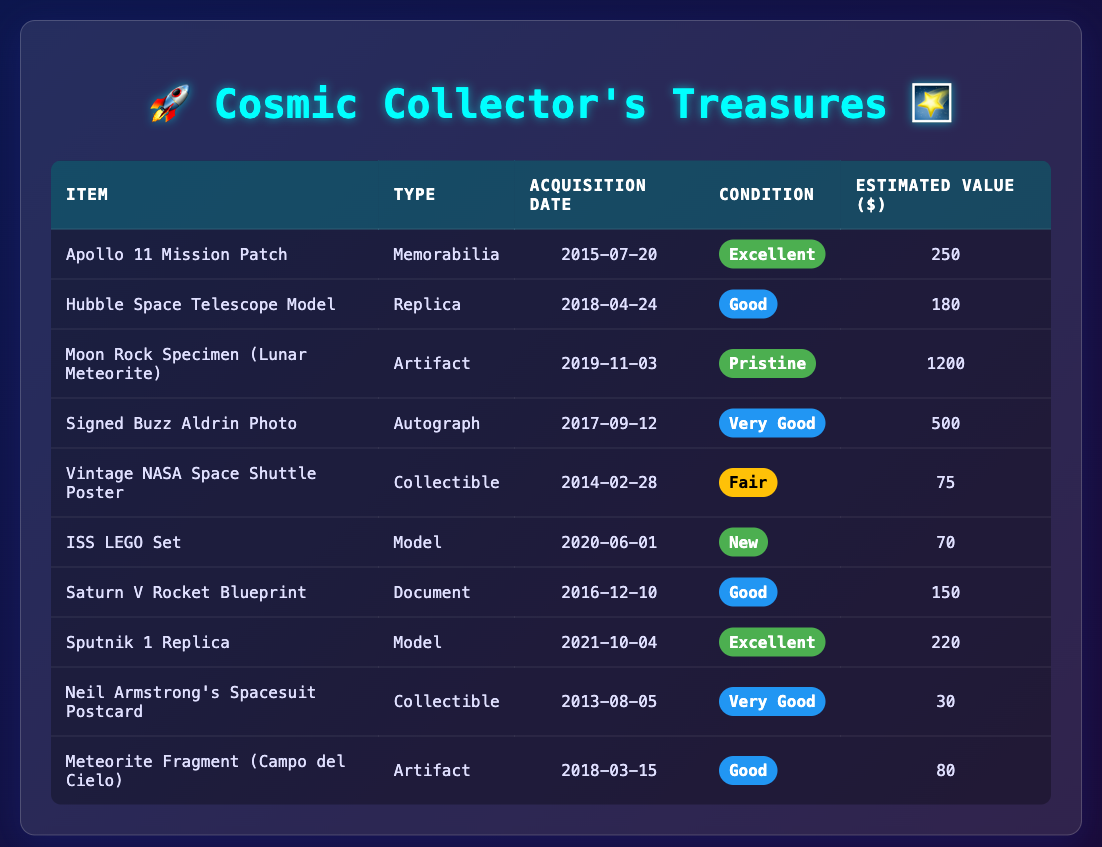What is the estimated value of the Moon Rock Specimen? The table lists the "Estimated Value ($)" of the Moon Rock Specimen (Lunar Meteorite) as 1200.
Answer: 1200 Which item has the best condition in your collection? The table indicates that the Moon Rock Specimen is in "Pristine" condition, which is the highest category. No other items match this condition.
Answer: Moon Rock Specimen (Lunar Meteorite) How many items in the collection have an estimated value greater than 200 dollars? The items with values greater than 200 dollars are the Apollo 11 Mission Patch (250), Signed Buzz Aldrin Photo (500), and the Moon Rock Specimen (1200). That totals to 3 items.
Answer: 3 What is the average estimated value of all memorabilia items? The memorabilia items are the Apollo 11 Mission Patch (250) and the Signed Buzz Aldrin Photo (500). Their total is 250 + 500 = 750, and there are 2 items, so the average is 750 / 2 = 375.
Answer: 375 Is the Vintage NASA Space Shuttle Poster in excellent condition? The table indicates that the Vintage NASA Space Shuttle Poster is in "Fair" condition, which is lower than "Excellent."
Answer: No What type of collectible has the lowest estimated value? Among the collectibles, Neil Armstrong's Spacesuit Postcard is listed at 30 dollars, which is lower than the Vintage NASA Space Shuttle Poster at 75 dollars.
Answer: Neil Armstrong's Spacesuit Postcard How many items are categorized as models? The table indicates two items categorized as models: the ISS LEGO Set and the Sputnik 1 Replica.
Answer: 2 Which items were acquired in 2018? The items acquired in 2018 are the Hubble Space Telescope Model (April 24) and the Meteorite Fragment (Campo del Cielo) (March 15).
Answer: Hubble Space Telescope Model, Meteorite Fragment (Campo del Cielo) 